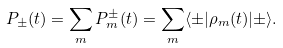Convert formula to latex. <formula><loc_0><loc_0><loc_500><loc_500>P _ { \pm } ( t ) = \sum _ { m } P _ { m } ^ { \pm } ( t ) = \sum _ { m } \langle \pm | \rho _ { m } ( t ) | \pm \rangle .</formula> 